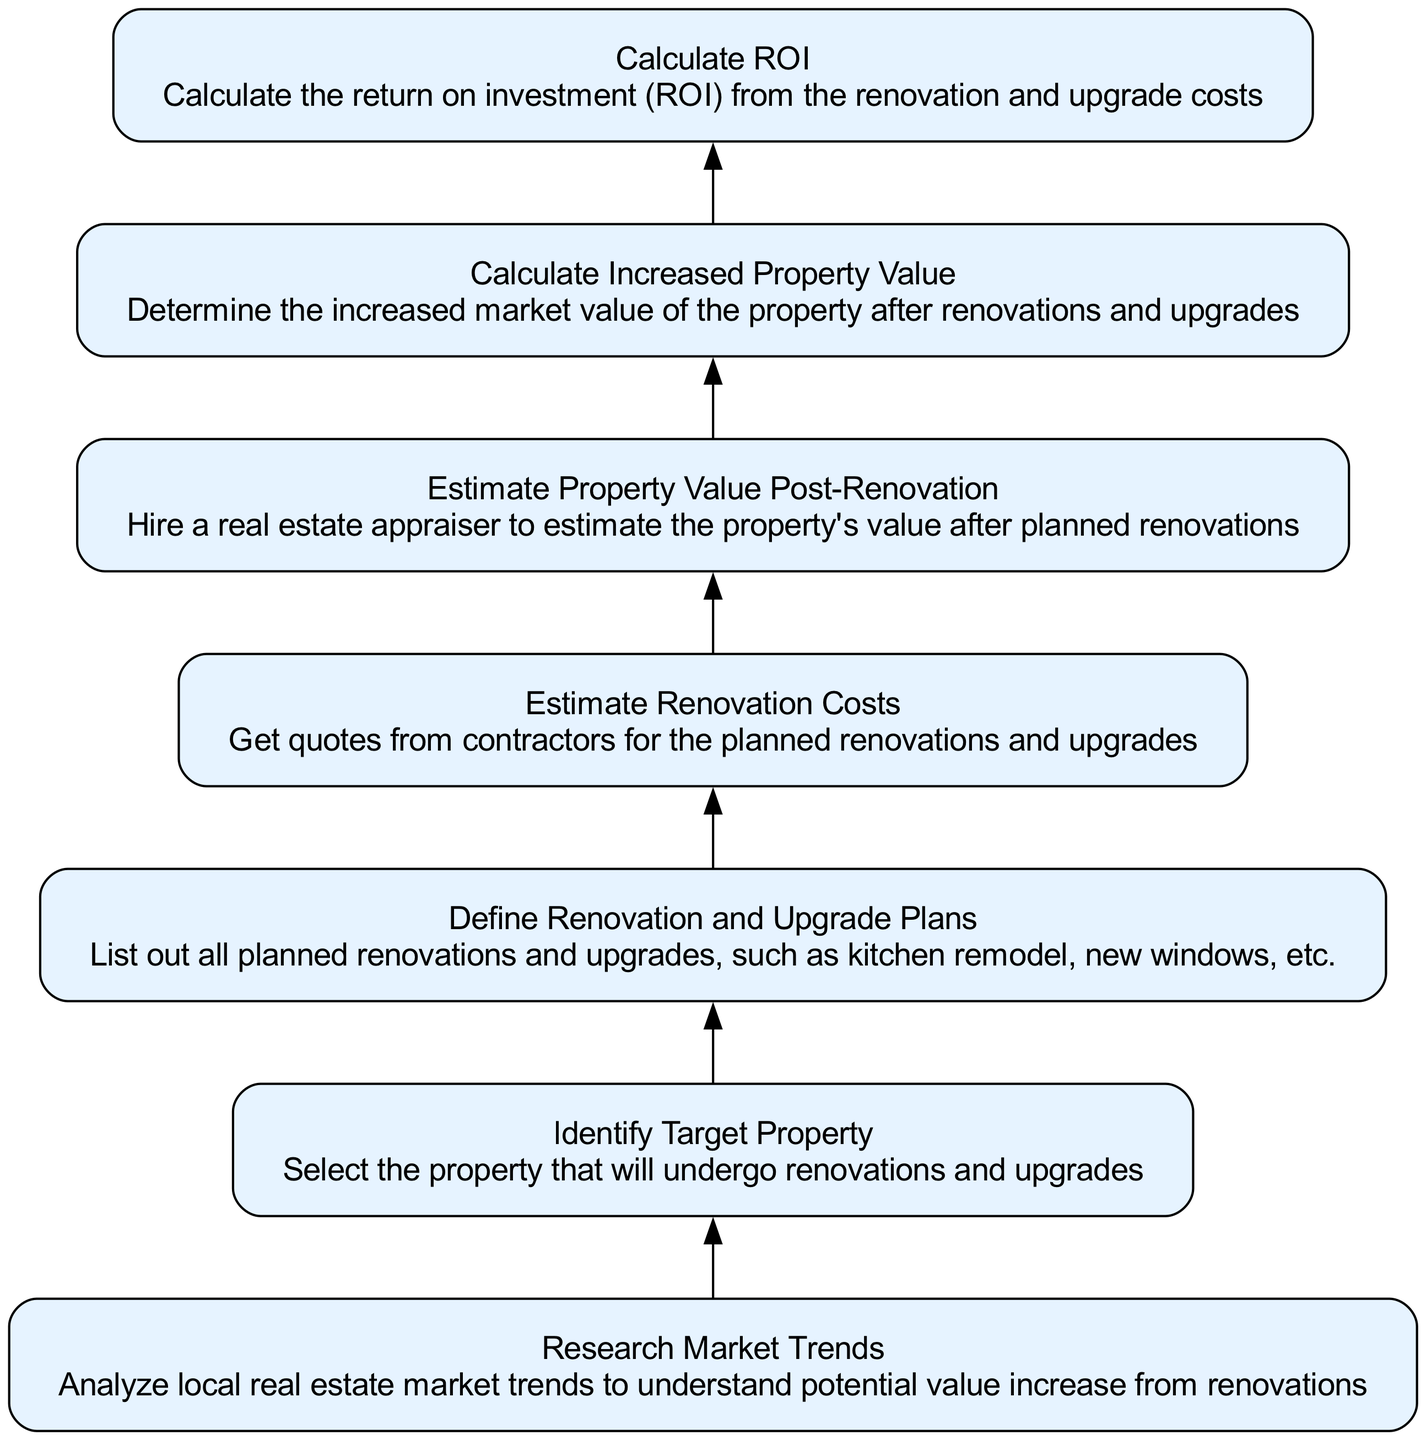What is the first step in the flowchart? The first step in the flowchart is to "Identify Target Property". It is the starting point of the process, indicating that a specific property must be chosen before any renovations or upgrades can be evaluated.
Answer: Identify Target Property How many total nodes are present in the flowchart? The flowchart consists of seven nodes, each representing a distinct process in the renovation and upgrade ROI calculation pathway.
Answer: 7 Which step follows after 'Estimate Renovation Costs'? The step that follows 'Estimate Renovation Costs' is 'Estimate Property Value Post-Renovation'. This indicates that once costs are estimated, the next action is to evaluate the post-renovation property value.
Answer: Estimate Property Value Post-Renovation What type of information is defined in the 'Define Renovation and Upgrade Plans' node? The 'Define Renovation and Upgrade Plans' node contains information about listing all the planned renovations and upgrades for the property, which is crucial for planning and budgeting purposes.
Answer: Listing planned renovations What is the last step in the flowchart process? The last step in the flowchart is 'Calculate ROI', which indicates that after gathering all necessary information about costs and increased property value, the final calculation of return on investment is performed.
Answer: Calculate ROI What relationship is indicated between 'Research Market Trends' and 'Identify Target Property'? The relationship indicates that 'Research Market Trends' must occur before 'Identify Target Property', suggesting that understanding the market is essential before selecting the property.
Answer: Research Market Trends precedes Identify Target Property What is the primary purpose of the flowchart? The primary purpose of the flowchart is to provide a structured sequence of steps to calculate the ROI from renovations and upgrades, guiding property investors through the essential processes.
Answer: Calculate ROI from renovations 